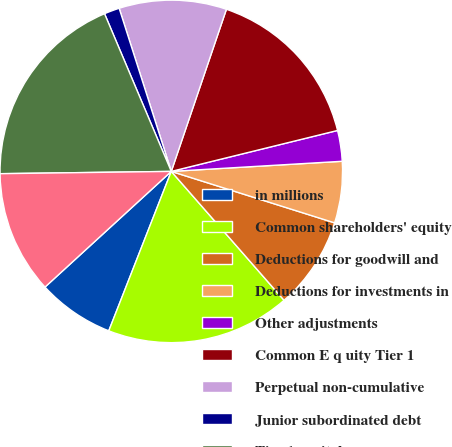Convert chart to OTSL. <chart><loc_0><loc_0><loc_500><loc_500><pie_chart><fcel>in millions<fcel>Common shareholders' equity<fcel>Deductions for goodwill and<fcel>Deductions for investments in<fcel>Other adjustments<fcel>Common E q uity Tier 1<fcel>Perpetual non-cumulative<fcel>Junior subordinated debt<fcel>Tier 1 capital<fcel>Qualifying subordinated debt<nl><fcel>7.25%<fcel>17.39%<fcel>8.7%<fcel>5.8%<fcel>2.9%<fcel>15.94%<fcel>10.14%<fcel>1.45%<fcel>18.84%<fcel>11.59%<nl></chart> 